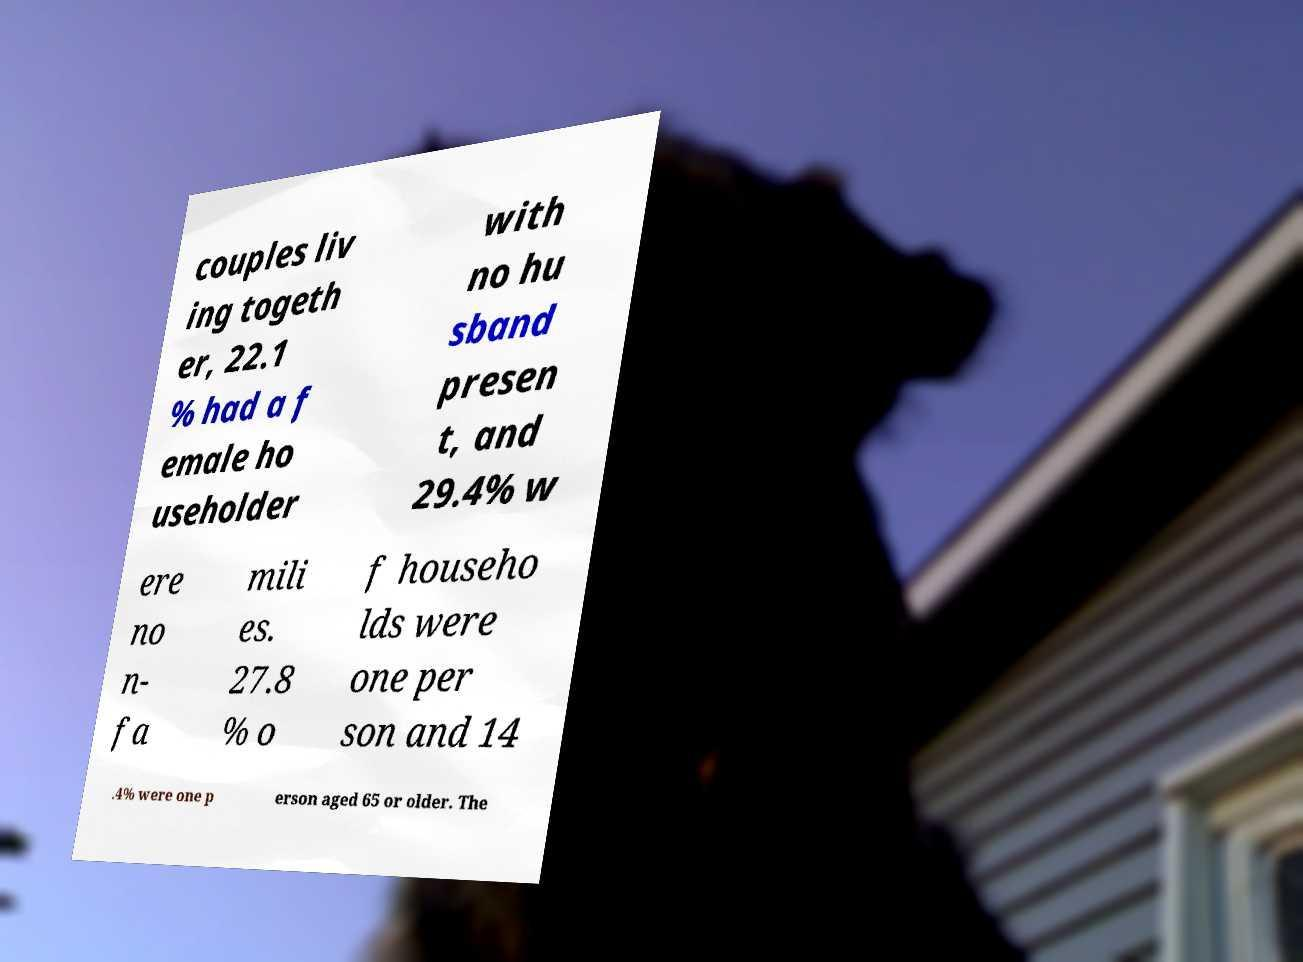For documentation purposes, I need the text within this image transcribed. Could you provide that? couples liv ing togeth er, 22.1 % had a f emale ho useholder with no hu sband presen t, and 29.4% w ere no n- fa mili es. 27.8 % o f househo lds were one per son and 14 .4% were one p erson aged 65 or older. The 